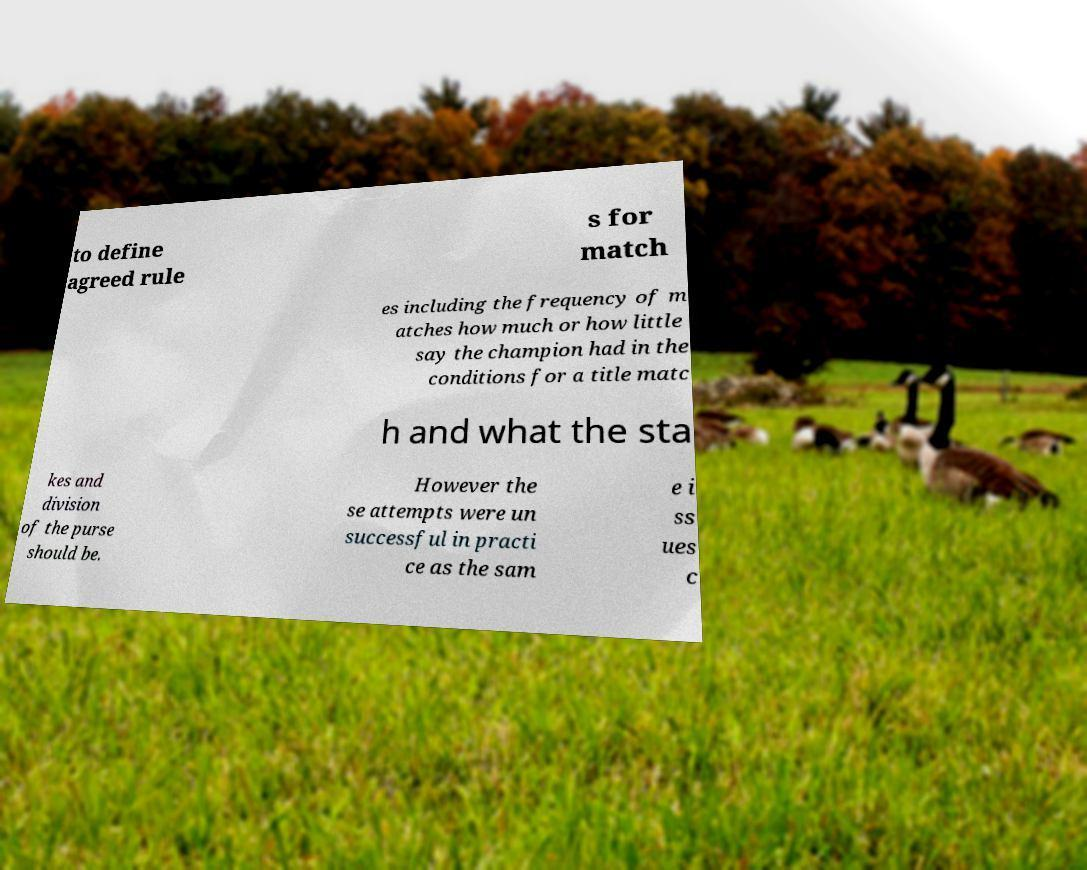Please read and relay the text visible in this image. What does it say? to define agreed rule s for match es including the frequency of m atches how much or how little say the champion had in the conditions for a title matc h and what the sta kes and division of the purse should be. However the se attempts were un successful in practi ce as the sam e i ss ues c 